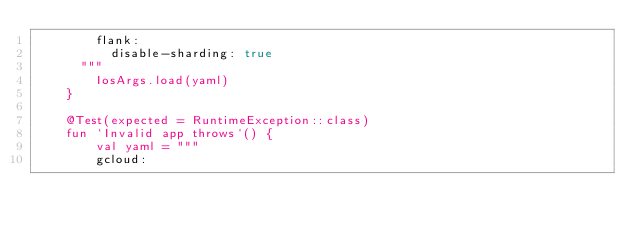Convert code to text. <code><loc_0><loc_0><loc_500><loc_500><_Kotlin_>        flank:
          disable-sharding: true
      """
        IosArgs.load(yaml)
    }

    @Test(expected = RuntimeException::class)
    fun `Invalid app throws`() {
        val yaml = """
        gcloud:</code> 